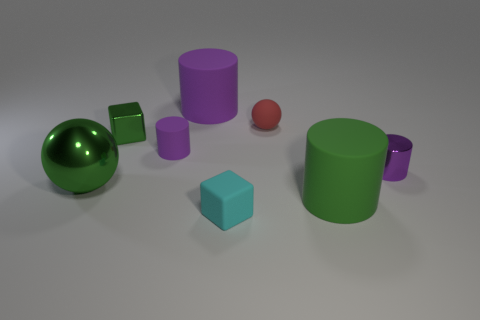How many purple cylinders must be subtracted to get 1 purple cylinders? 2 Subtract all green spheres. How many purple cylinders are left? 3 Add 1 red objects. How many objects exist? 9 Subtract all brown cylinders. Subtract all gray spheres. How many cylinders are left? 4 Subtract all cubes. How many objects are left? 6 Subtract 0 red cylinders. How many objects are left? 8 Subtract all large metallic objects. Subtract all small objects. How many objects are left? 2 Add 6 small green blocks. How many small green blocks are left? 7 Add 8 purple metal spheres. How many purple metal spheres exist? 8 